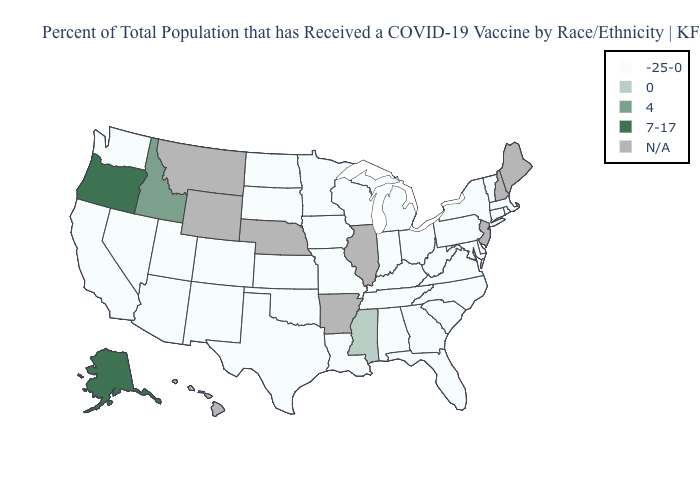How many symbols are there in the legend?
Quick response, please. 5. What is the value of Arizona?
Concise answer only. -25-0. What is the highest value in the USA?
Concise answer only. 7-17. What is the highest value in the South ?
Give a very brief answer. 0. What is the highest value in the USA?
Short answer required. 7-17. What is the lowest value in states that border Nebraska?
Keep it brief. -25-0. Does the map have missing data?
Short answer required. Yes. Among the states that border Oregon , which have the lowest value?
Concise answer only. California, Nevada, Washington. What is the highest value in states that border Arkansas?
Short answer required. 0. What is the value of Hawaii?
Short answer required. N/A. What is the value of New Hampshire?
Concise answer only. N/A. Name the states that have a value in the range -25-0?
Answer briefly. Alabama, Arizona, California, Colorado, Connecticut, Delaware, Florida, Georgia, Indiana, Iowa, Kansas, Kentucky, Louisiana, Maryland, Massachusetts, Michigan, Minnesota, Missouri, Nevada, New Mexico, New York, North Carolina, North Dakota, Ohio, Oklahoma, Pennsylvania, Rhode Island, South Carolina, South Dakota, Tennessee, Texas, Utah, Vermont, Virginia, Washington, West Virginia, Wisconsin. What is the value of Texas?
Quick response, please. -25-0. What is the lowest value in the South?
Write a very short answer. -25-0. 